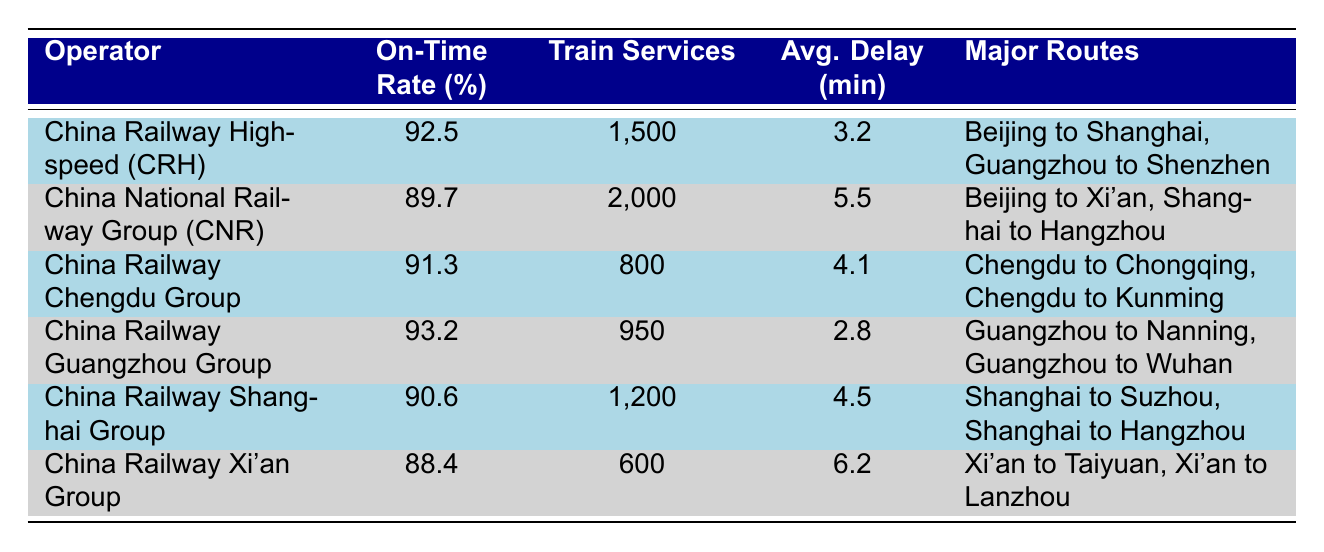What is the On-Time Performance Rate of China Railway High-speed (CRH)? The table lists the On-Time Performance Rate for China Railway High-speed (CRH) as 92.5%.
Answer: 92.5% Which operator has the highest average delay? By comparing the Average Delay values in the table, China Railway Xi'an Group has the highest at 6.2 minutes.
Answer: 6.2 minutes How many train services does China National Railway Group (CNR) operate? The table shows that China National Railway Group (CNR) operates 2,000 train services.
Answer: 2,000 Is it true that China Railway Guangzhou Group has an On-Time Performance Rate above 90%? Yes, the table shows that China Railway Guangzhou Group has an On-Time Performance Rate of 93.2%, which is above 90%.
Answer: Yes What is the average On-Time Performance Rate of all operators listed? The On-Time Performance Rates are 92.5, 89.7, 91.3, 93.2, 90.6, and 88.4. Adding these gives 525.7, and dividing by 6 results in an average of approximately 87.62.
Answer: 90.17 What is the difference in On-Time Performance Rates between the best and worst operator? The best On-Time Performance Rate is 93.2% (China Railway Guangzhou Group) and the worst is 88.4% (China Railway Xi'an Group). The difference is 93.2 - 88.4 = 4.8%.
Answer: 4.8% How many operators have an On-Time Performance Rate above 90%? China Railway High-speed (CRH), China Railway Chengdu Group, and China Railway Guangzhou Group all have rates above 90%. Therefore, there are 3 operators.
Answer: 3 What is the total number of train services operated by all groups combined? The total is calculated by adding the number of train services: 1,500 + 2,000 + 800 + 950 + 1,200 + 600 = 6,050.
Answer: 6,050 Which major route is featured by both China Railway Guangzhou Group and China Railway High-speed (CRH)? By reviewing the major routes listed, both operators feature routes to Guangzhou (Guangzhou to Nanning for China Railway Guangzhou Group and Guangzhou to Shenzhen for China Railway High-speed).
Answer: No common route 